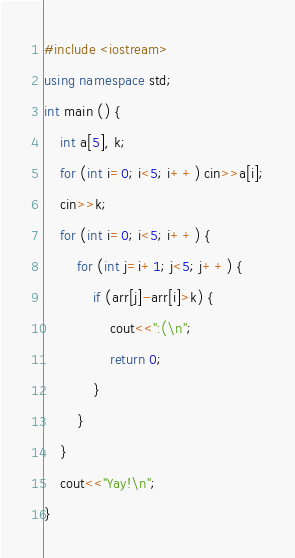Convert code to text. <code><loc_0><loc_0><loc_500><loc_500><_C++_>#include <iostream>
using namespace std;
int main () {
    int a[5], k;
    for (int i=0; i<5; i++) cin>>a[i];
    cin>>k;
    for (int i=0; i<5; i++) {
        for (int j=i+1; j<5; j++) {
            if (arr[j]-arr[i]>k) {
                cout<<":(\n";
                return 0;
            }
        }
    }
    cout<<"Yay!\n";
}</code> 